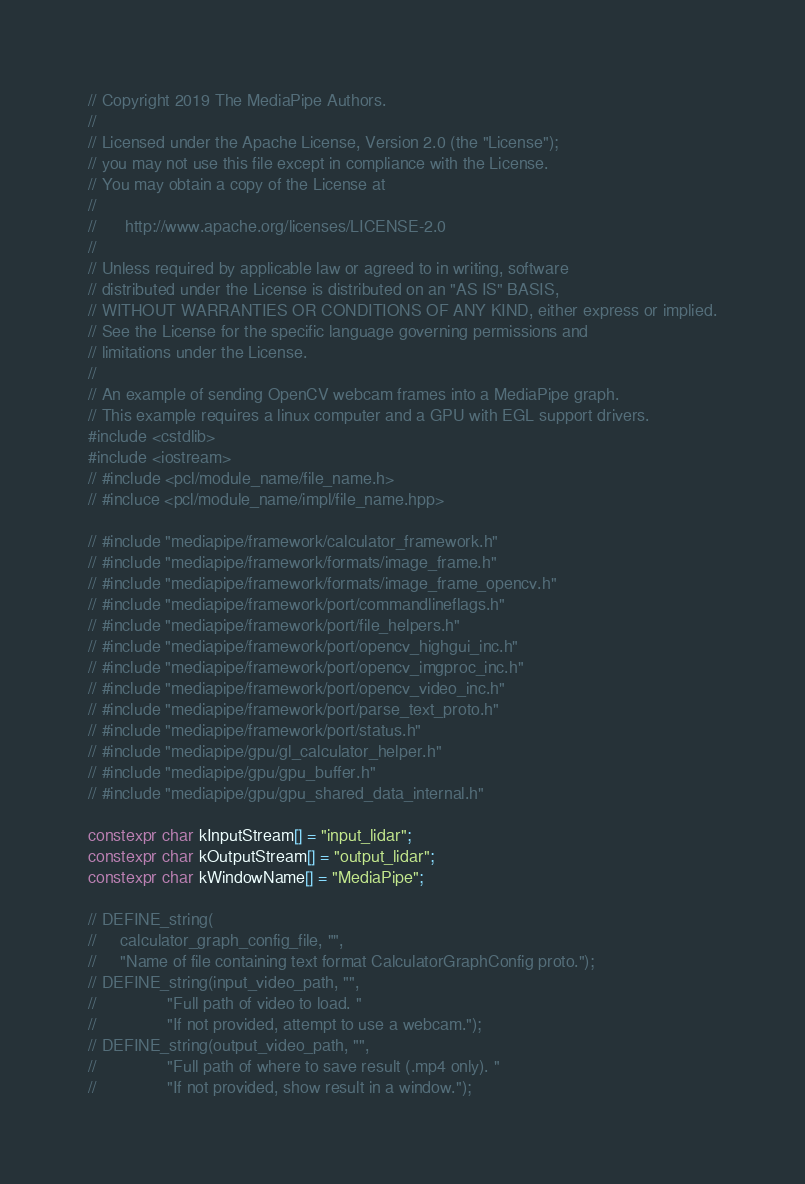<code> <loc_0><loc_0><loc_500><loc_500><_C++_>// Copyright 2019 The MediaPipe Authors.
//
// Licensed under the Apache License, Version 2.0 (the "License");
// you may not use this file except in compliance with the License.
// You may obtain a copy of the License at
//
//      http://www.apache.org/licenses/LICENSE-2.0
//
// Unless required by applicable law or agreed to in writing, software
// distributed under the License is distributed on an "AS IS" BASIS,
// WITHOUT WARRANTIES OR CONDITIONS OF ANY KIND, either express or implied.
// See the License for the specific language governing permissions and
// limitations under the License.
//
// An example of sending OpenCV webcam frames into a MediaPipe graph.
// This example requires a linux computer and a GPU with EGL support drivers.
#include <cstdlib>
#include <iostream>
// #include <pcl/module_name/file_name.h>
// #incluce <pcl/module_name/impl/file_name.hpp>

// #include "mediapipe/framework/calculator_framework.h"
// #include "mediapipe/framework/formats/image_frame.h"
// #include "mediapipe/framework/formats/image_frame_opencv.h"
// #include "mediapipe/framework/port/commandlineflags.h"
// #include "mediapipe/framework/port/file_helpers.h"
// #include "mediapipe/framework/port/opencv_highgui_inc.h"
// #include "mediapipe/framework/port/opencv_imgproc_inc.h"
// #include "mediapipe/framework/port/opencv_video_inc.h"
// #include "mediapipe/framework/port/parse_text_proto.h"
// #include "mediapipe/framework/port/status.h"
// #include "mediapipe/gpu/gl_calculator_helper.h"
// #include "mediapipe/gpu/gpu_buffer.h"
// #include "mediapipe/gpu/gpu_shared_data_internal.h"

constexpr char kInputStream[] = "input_lidar";
constexpr char kOutputStream[] = "output_lidar";
constexpr char kWindowName[] = "MediaPipe";

// DEFINE_string(
//     calculator_graph_config_file, "",
//     "Name of file containing text format CalculatorGraphConfig proto.");
// DEFINE_string(input_video_path, "",
//               "Full path of video to load. "
//               "If not provided, attempt to use a webcam.");
// DEFINE_string(output_video_path, "",
//               "Full path of where to save result (.mp4 only). "
//               "If not provided, show result in a window.");
</code> 